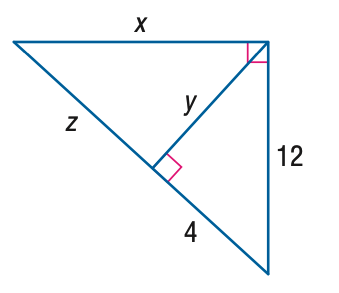Question: Find x.
Choices:
A. 24
B. 24 \sqrt { 2 }
C. 36
D. 24 \sqrt { 3 }
Answer with the letter. Answer: B Question: Find y.
Choices:
A. 8
B. 8 \sqrt { 2 }
C. 12
D. 8 \sqrt { 3 }
Answer with the letter. Answer: B 